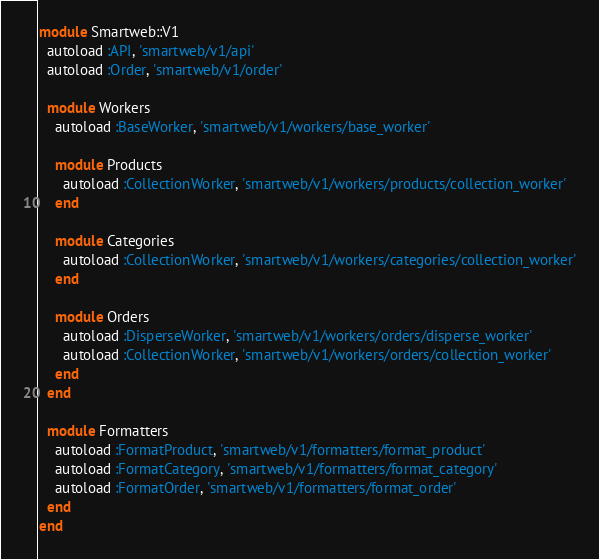<code> <loc_0><loc_0><loc_500><loc_500><_Ruby_>module Smartweb::V1
  autoload :API, 'smartweb/v1/api'
  autoload :Order, 'smartweb/v1/order'

  module Workers
    autoload :BaseWorker, 'smartweb/v1/workers/base_worker'

    module Products
      autoload :CollectionWorker, 'smartweb/v1/workers/products/collection_worker'
    end

    module Categories
      autoload :CollectionWorker, 'smartweb/v1/workers/categories/collection_worker'
    end

    module Orders
      autoload :DisperseWorker, 'smartweb/v1/workers/orders/disperse_worker'
      autoload :CollectionWorker, 'smartweb/v1/workers/orders/collection_worker'
    end
  end

  module Formatters
    autoload :FormatProduct, 'smartweb/v1/formatters/format_product'
    autoload :FormatCategory, 'smartweb/v1/formatters/format_category'
    autoload :FormatOrder, 'smartweb/v1/formatters/format_order'
  end
end
</code> 